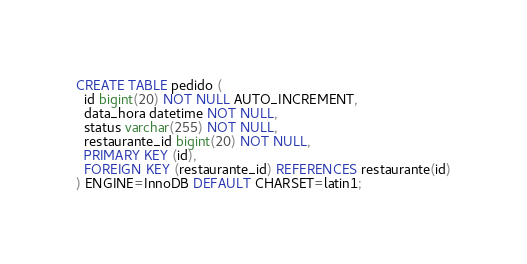Convert code to text. <code><loc_0><loc_0><loc_500><loc_500><_SQL_>CREATE TABLE pedido (
  id bigint(20) NOT NULL AUTO_INCREMENT,
  data_hora datetime NOT NULL,
  status varchar(255) NOT NULL,
  restaurante_id bigint(20) NOT NULL,
  PRIMARY KEY (id),
  FOREIGN KEY (restaurante_id) REFERENCES restaurante(id)
) ENGINE=InnoDB DEFAULT CHARSET=latin1;
</code> 